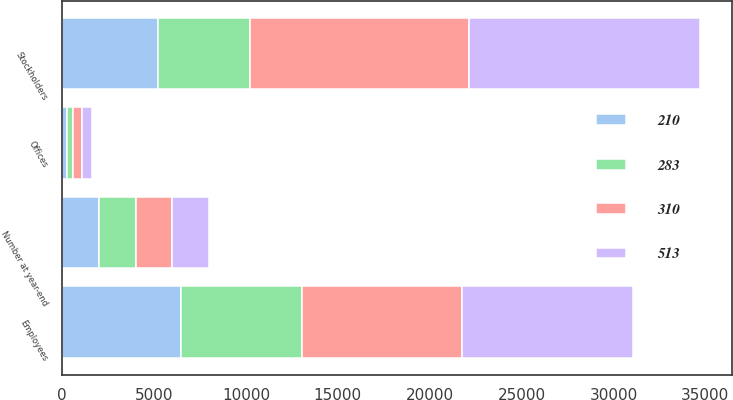<chart> <loc_0><loc_0><loc_500><loc_500><stacked_bar_chart><ecel><fcel>Number at year-end<fcel>Stockholders<fcel>Employees<fcel>Offices<nl><fcel>513<fcel>2001<fcel>12565<fcel>9291<fcel>513<nl><fcel>310<fcel>2000<fcel>11936<fcel>8736<fcel>488<nl><fcel>283<fcel>1999<fcel>4991<fcel>6569<fcel>310<nl><fcel>210<fcel>1998<fcel>5207<fcel>6467<fcel>283<nl></chart> 